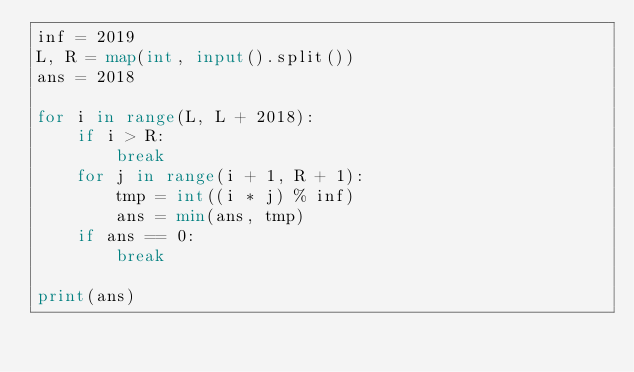<code> <loc_0><loc_0><loc_500><loc_500><_Python_>inf = 2019
L, R = map(int, input().split())
ans = 2018

for i in range(L, L + 2018):
    if i > R:
        break
    for j in range(i + 1, R + 1):
        tmp = int((i * j) % inf)
        ans = min(ans, tmp)
    if ans == 0:
        break

print(ans)
</code> 